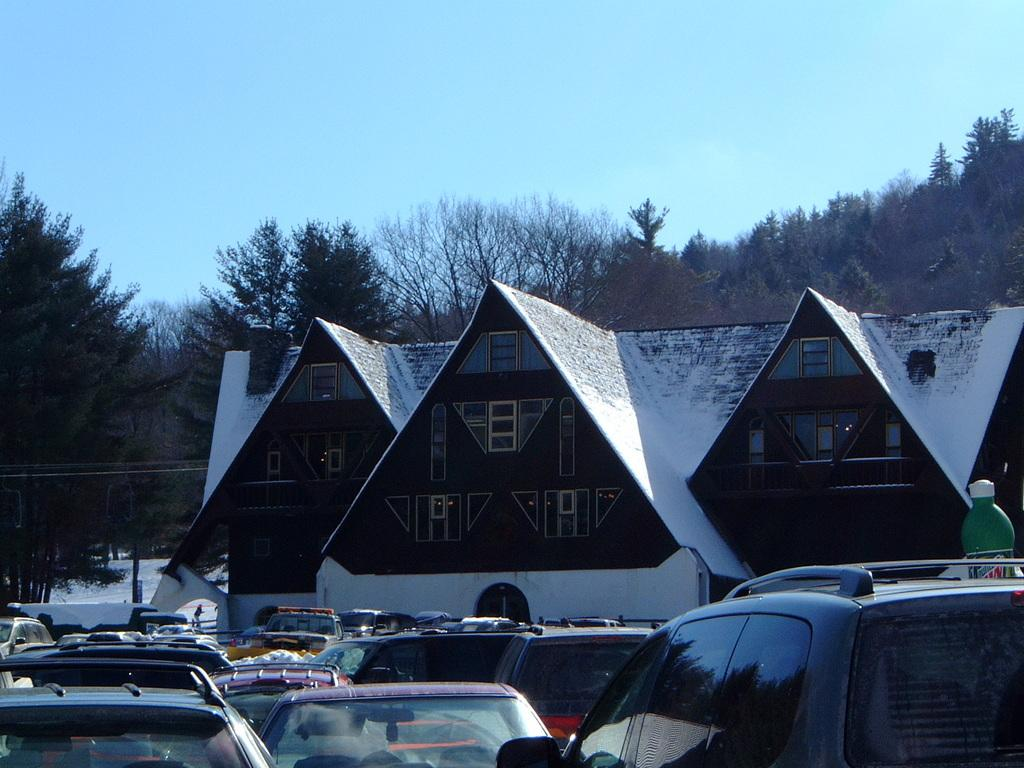What type of vehicles are in the front of the image? There are cars in the front of the image. What structure can be seen in the background of the image? There is a house in the background of the image. What type of natural vegetation is visible in the background of the image? There are trees in the background of the image. Can you tell me how deep the water is in the image? There is no water present in the image. Is there a railway visible in the image? There is no railway present in the image. 